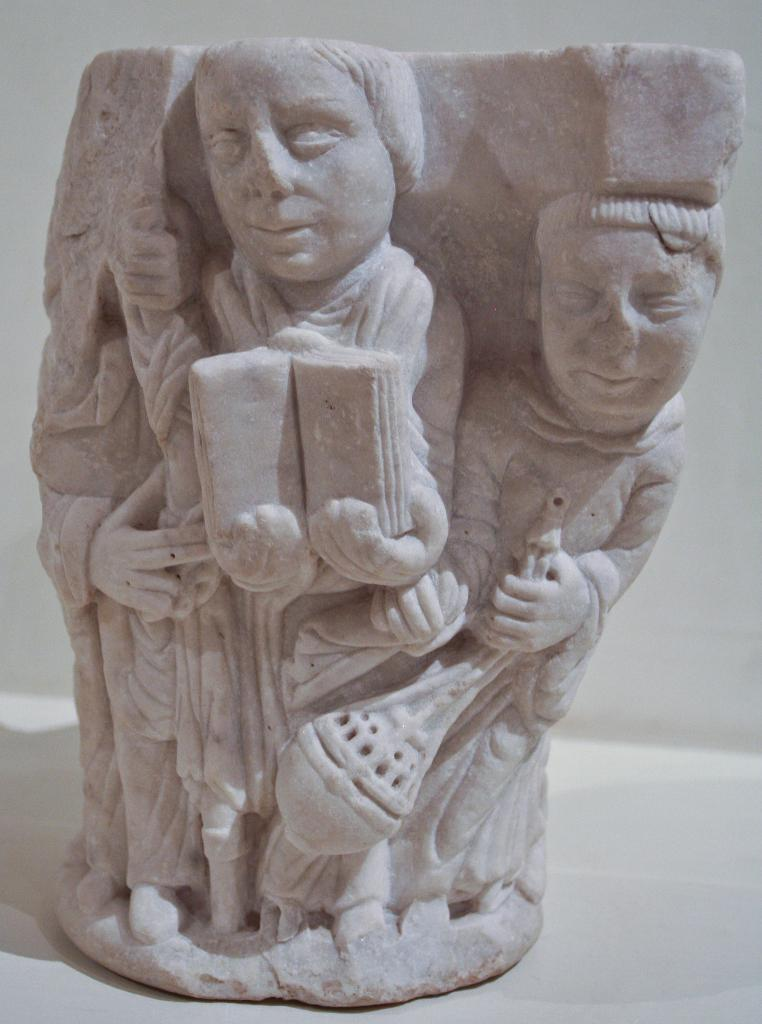What is the main subject of the image? There is a sculpture in the image. Can you describe the setting of the image? There is a wall in the background of the image. What type of discussion is taking place in front of the sculpture in the image? There is no discussion taking place in the image; it only features a sculpture and a wall in the background. Is there a veil covering the sculpture in the image? There is no mention of a veil in the provided facts, so we cannot determine if it is present or not. 